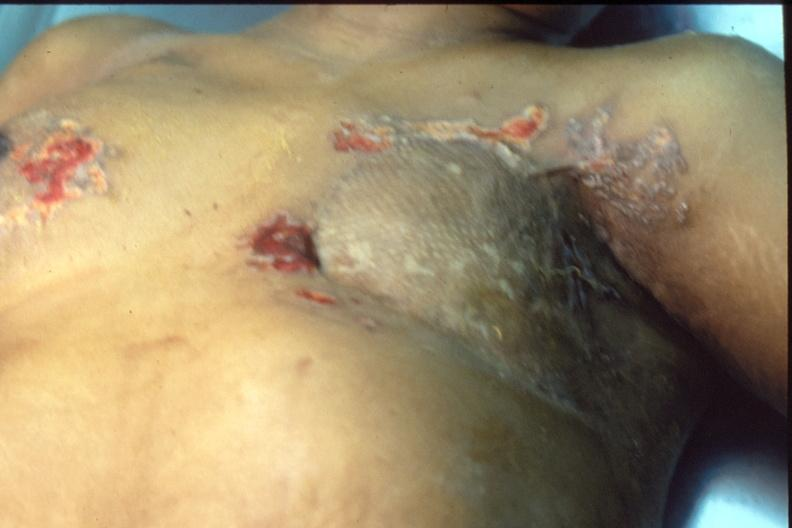does this image show mastectomy scars with skin metastases?
Answer the question using a single word or phrase. Yes 